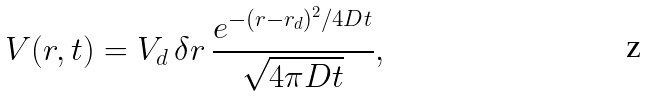Convert formula to latex. <formula><loc_0><loc_0><loc_500><loc_500>V ( r , t ) = V _ { d } \, \delta r \, \frac { e ^ { - ( r - r _ { d } ) ^ { 2 } / 4 D t } } { \sqrt { 4 \pi D t } } ,</formula> 